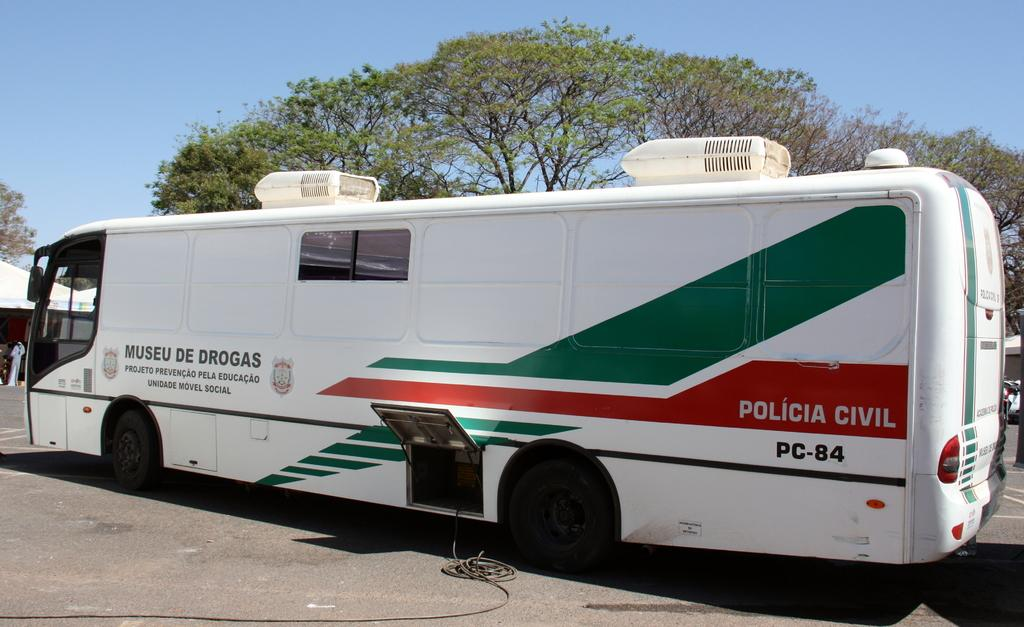<image>
Give a short and clear explanation of the subsequent image. a big white bus with green and red for the Policia Civil 